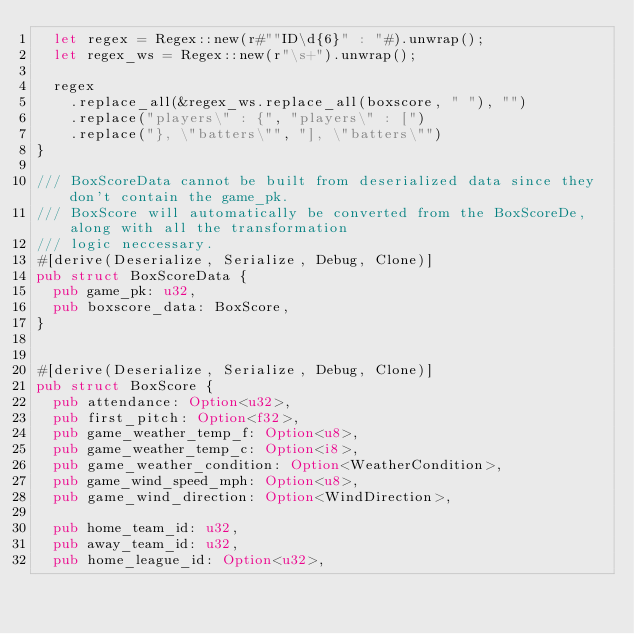<code> <loc_0><loc_0><loc_500><loc_500><_Rust_>  let regex = Regex::new(r#""ID\d{6}" : "#).unwrap();
  let regex_ws = Regex::new(r"\s+").unwrap();

  regex
    .replace_all(&regex_ws.replace_all(boxscore, " "), "")
    .replace("players\" : {", "players\" : [")
    .replace("}, \"batters\"", "], \"batters\"")
}

/// BoxScoreData cannot be built from deserialized data since they don't contain the game_pk.
/// BoxScore will automatically be converted from the BoxScoreDe, along with all the transformation
/// logic neccessary. 
#[derive(Deserialize, Serialize, Debug, Clone)]
pub struct BoxScoreData {
  pub game_pk: u32,
  pub boxscore_data: BoxScore,
}


#[derive(Deserialize, Serialize, Debug, Clone)]
pub struct BoxScore {
  pub attendance: Option<u32>,
  pub first_pitch: Option<f32>,
  pub game_weather_temp_f: Option<u8>,
  pub game_weather_temp_c: Option<i8>,
  pub game_weather_condition: Option<WeatherCondition>,
  pub game_wind_speed_mph: Option<u8>,
  pub game_wind_direction: Option<WindDirection>,
  
  pub home_team_id: u32,
  pub away_team_id: u32,
  pub home_league_id: Option<u32>,</code> 